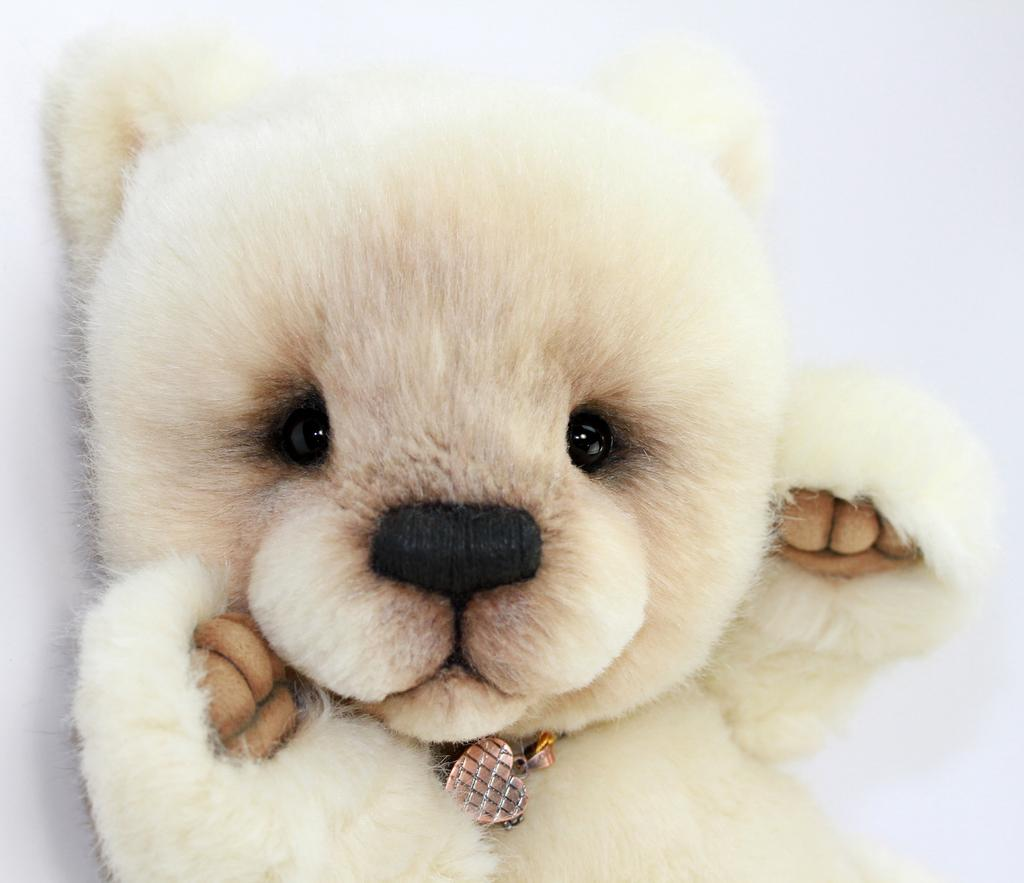What is the main subject of the image? There is a teddy-bear in the image. Can you describe the appearance of the teddy-bear? The teddy-bear is white and black in color. What is the color of the background in the image? The background of the image is white. How many gold coins does the teddy-bear have in the image? There are no gold coins present in the image; it features a white and black teddy-bear against a white background. 